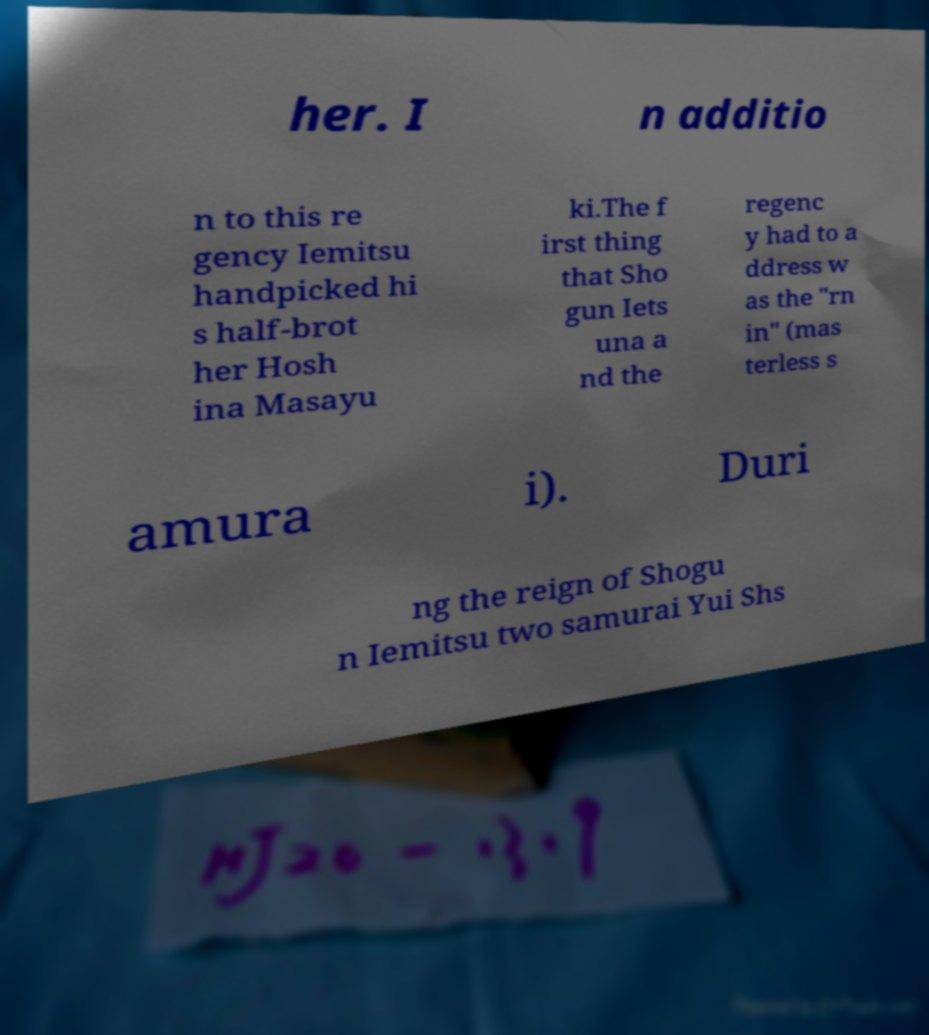Can you read and provide the text displayed in the image?This photo seems to have some interesting text. Can you extract and type it out for me? her. I n additio n to this re gency Iemitsu handpicked hi s half-brot her Hosh ina Masayu ki.The f irst thing that Sho gun Iets una a nd the regenc y had to a ddress w as the "rn in" (mas terless s amura i). Duri ng the reign of Shogu n Iemitsu two samurai Yui Shs 